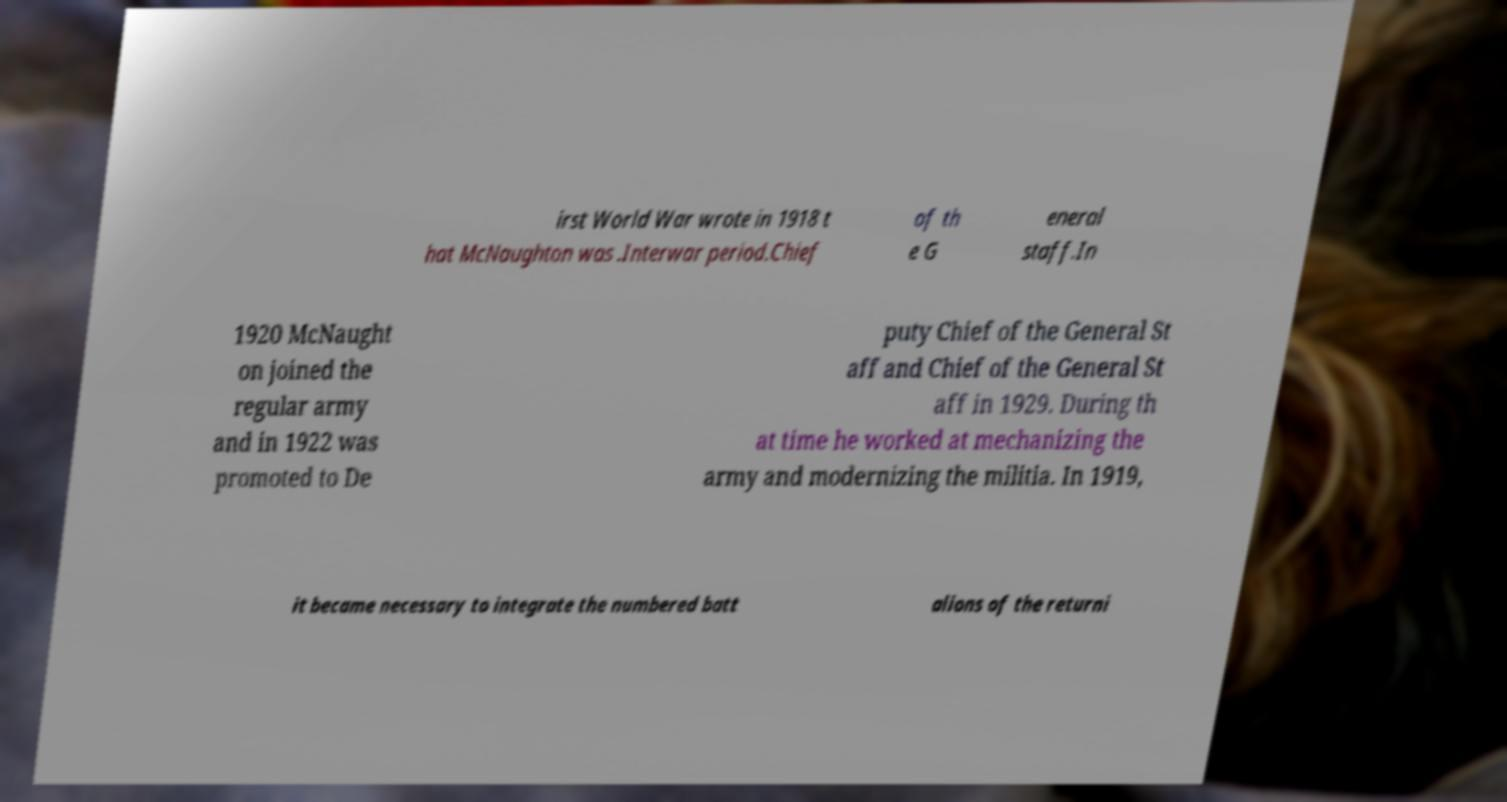There's text embedded in this image that I need extracted. Can you transcribe it verbatim? irst World War wrote in 1918 t hat McNaughton was .Interwar period.Chief of th e G eneral staff.In 1920 McNaught on joined the regular army and in 1922 was promoted to De puty Chief of the General St aff and Chief of the General St aff in 1929. During th at time he worked at mechanizing the army and modernizing the militia. In 1919, it became necessary to integrate the numbered batt alions of the returni 